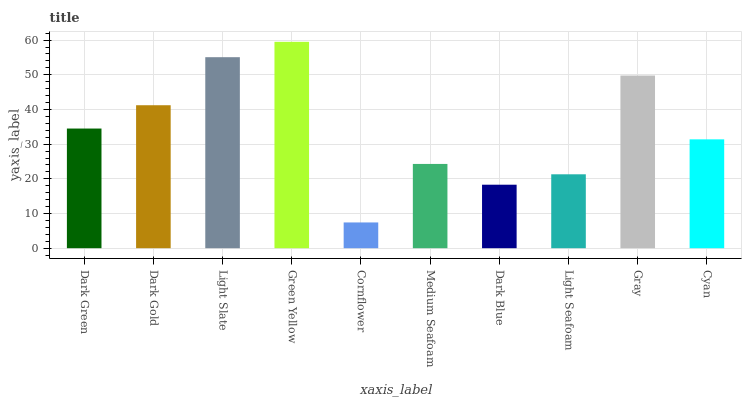Is Cornflower the minimum?
Answer yes or no. Yes. Is Green Yellow the maximum?
Answer yes or no. Yes. Is Dark Gold the minimum?
Answer yes or no. No. Is Dark Gold the maximum?
Answer yes or no. No. Is Dark Gold greater than Dark Green?
Answer yes or no. Yes. Is Dark Green less than Dark Gold?
Answer yes or no. Yes. Is Dark Green greater than Dark Gold?
Answer yes or no. No. Is Dark Gold less than Dark Green?
Answer yes or no. No. Is Dark Green the high median?
Answer yes or no. Yes. Is Cyan the low median?
Answer yes or no. Yes. Is Dark Gold the high median?
Answer yes or no. No. Is Gray the low median?
Answer yes or no. No. 